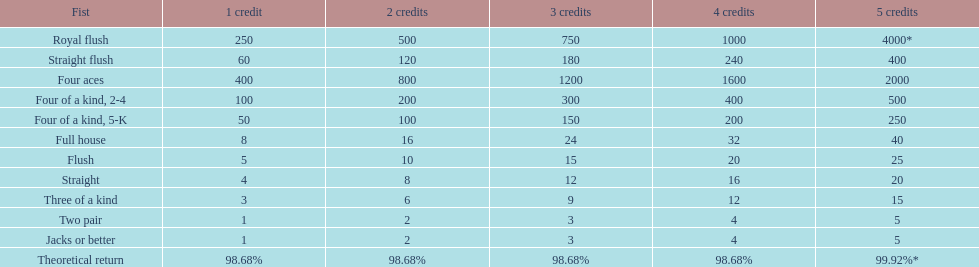Could you parse the entire table as a dict? {'header': ['Fist', '1 credit', '2 credits', '3 credits', '4 credits', '5 credits'], 'rows': [['Royal flush', '250', '500', '750', '1000', '4000*'], ['Straight flush', '60', '120', '180', '240', '400'], ['Four aces', '400', '800', '1200', '1600', '2000'], ['Four of a kind, 2-4', '100', '200', '300', '400', '500'], ['Four of a kind, 5-K', '50', '100', '150', '200', '250'], ['Full house', '8', '16', '24', '32', '40'], ['Flush', '5', '10', '15', '20', '25'], ['Straight', '4', '8', '12', '16', '20'], ['Three of a kind', '3', '6', '9', '12', '15'], ['Two pair', '1', '2', '3', '4', '5'], ['Jacks or better', '1', '2', '3', '4', '5'], ['Theoretical return', '98.68%', '98.68%', '98.68%', '98.68%', '99.92%*']]} Are four 5s more or less valuable than four 2s? Less. 